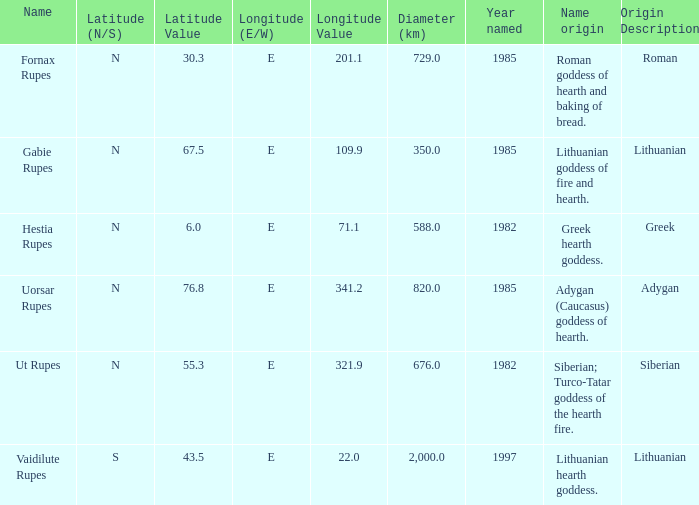At a latitude of 6 350.0. 